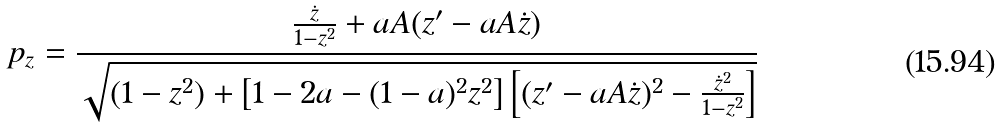<formula> <loc_0><loc_0><loc_500><loc_500>p _ { z } = \frac { \frac { \dot { z } } { 1 - z ^ { 2 } } + a A ( z ^ { \prime } - a A \dot { z } ) } { \sqrt { ( 1 - z ^ { 2 } ) + \left [ 1 - 2 a - ( 1 - a ) ^ { 2 } z ^ { 2 } \right ] \left [ ( z ^ { \prime } - a A \dot { z } ) ^ { 2 } - \frac { \dot { z } ^ { 2 } } { 1 - z ^ { 2 } } \right ] } }</formula> 